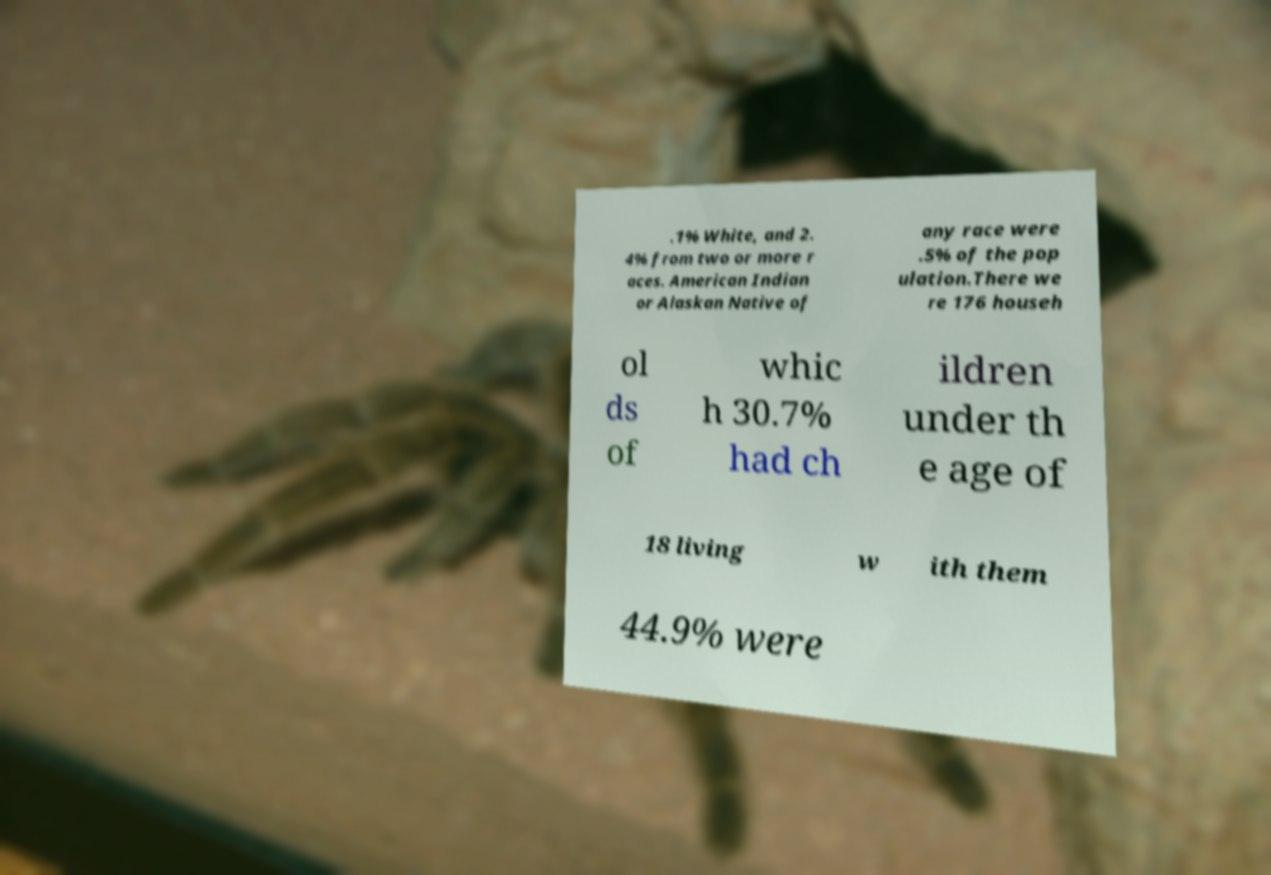I need the written content from this picture converted into text. Can you do that? .1% White, and 2. 4% from two or more r aces. American Indian or Alaskan Native of any race were .5% of the pop ulation.There we re 176 househ ol ds of whic h 30.7% had ch ildren under th e age of 18 living w ith them 44.9% were 